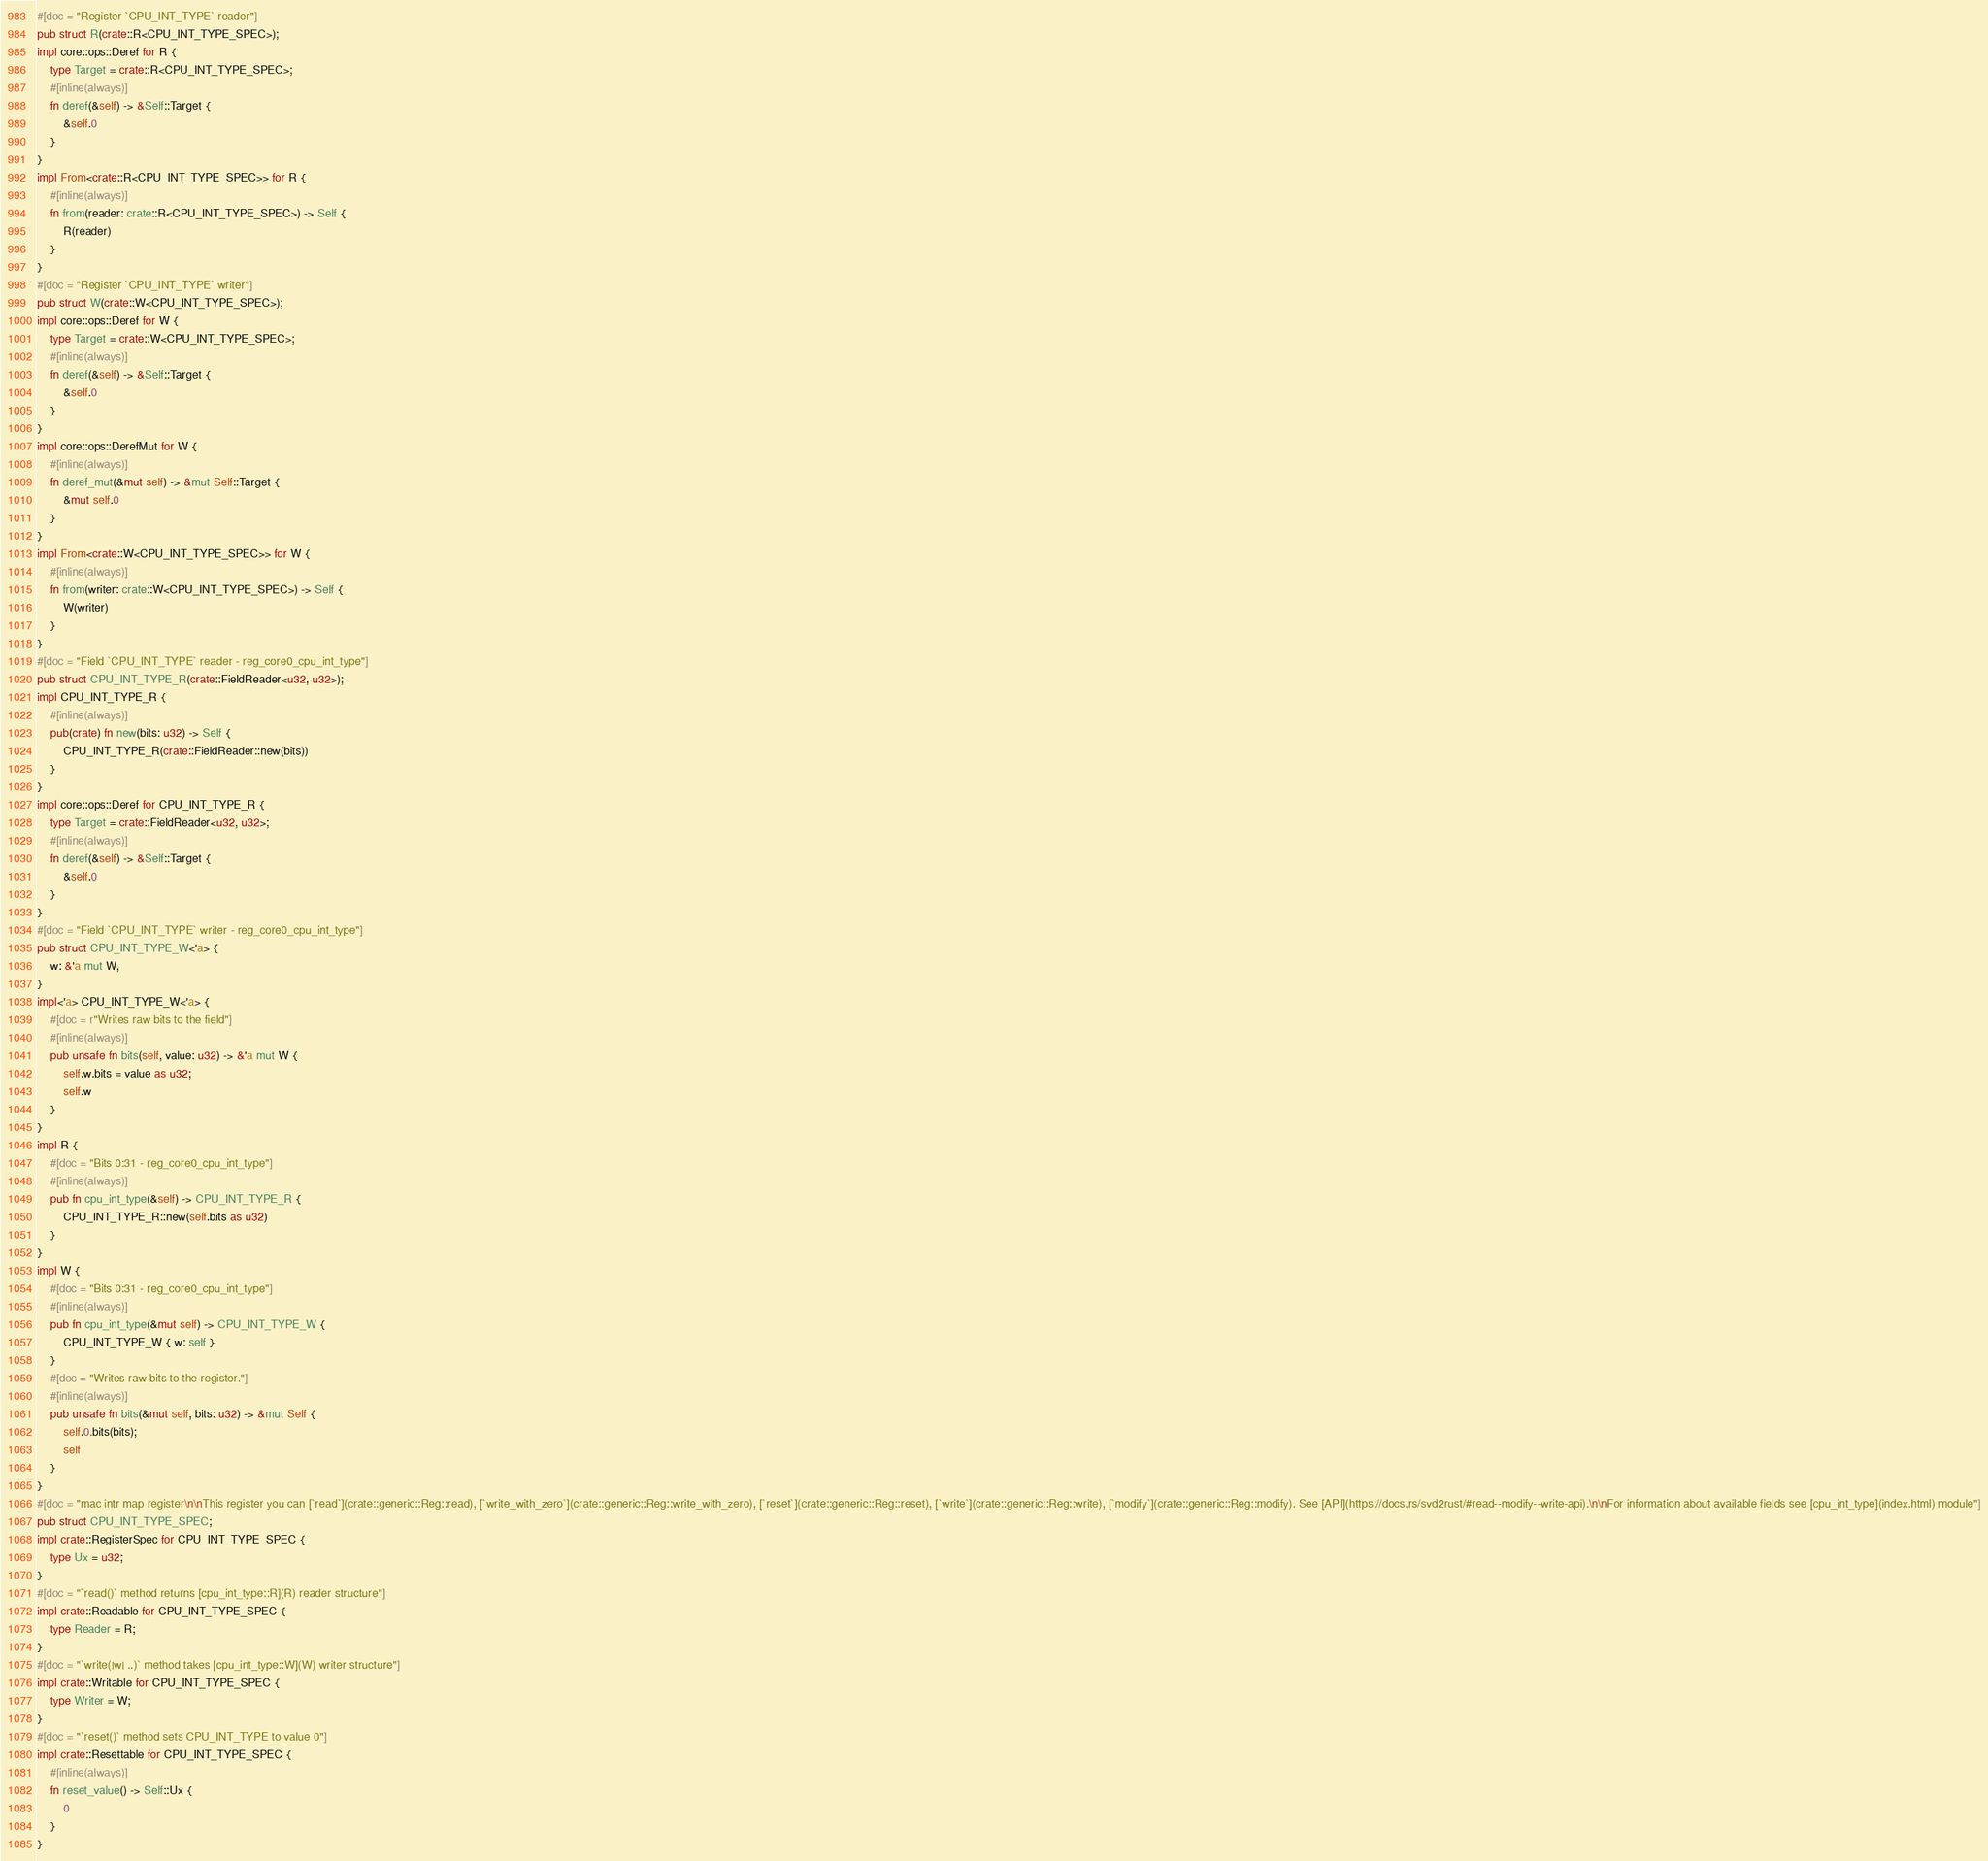<code> <loc_0><loc_0><loc_500><loc_500><_Rust_>#[doc = "Register `CPU_INT_TYPE` reader"]
pub struct R(crate::R<CPU_INT_TYPE_SPEC>);
impl core::ops::Deref for R {
    type Target = crate::R<CPU_INT_TYPE_SPEC>;
    #[inline(always)]
    fn deref(&self) -> &Self::Target {
        &self.0
    }
}
impl From<crate::R<CPU_INT_TYPE_SPEC>> for R {
    #[inline(always)]
    fn from(reader: crate::R<CPU_INT_TYPE_SPEC>) -> Self {
        R(reader)
    }
}
#[doc = "Register `CPU_INT_TYPE` writer"]
pub struct W(crate::W<CPU_INT_TYPE_SPEC>);
impl core::ops::Deref for W {
    type Target = crate::W<CPU_INT_TYPE_SPEC>;
    #[inline(always)]
    fn deref(&self) -> &Self::Target {
        &self.0
    }
}
impl core::ops::DerefMut for W {
    #[inline(always)]
    fn deref_mut(&mut self) -> &mut Self::Target {
        &mut self.0
    }
}
impl From<crate::W<CPU_INT_TYPE_SPEC>> for W {
    #[inline(always)]
    fn from(writer: crate::W<CPU_INT_TYPE_SPEC>) -> Self {
        W(writer)
    }
}
#[doc = "Field `CPU_INT_TYPE` reader - reg_core0_cpu_int_type"]
pub struct CPU_INT_TYPE_R(crate::FieldReader<u32, u32>);
impl CPU_INT_TYPE_R {
    #[inline(always)]
    pub(crate) fn new(bits: u32) -> Self {
        CPU_INT_TYPE_R(crate::FieldReader::new(bits))
    }
}
impl core::ops::Deref for CPU_INT_TYPE_R {
    type Target = crate::FieldReader<u32, u32>;
    #[inline(always)]
    fn deref(&self) -> &Self::Target {
        &self.0
    }
}
#[doc = "Field `CPU_INT_TYPE` writer - reg_core0_cpu_int_type"]
pub struct CPU_INT_TYPE_W<'a> {
    w: &'a mut W,
}
impl<'a> CPU_INT_TYPE_W<'a> {
    #[doc = r"Writes raw bits to the field"]
    #[inline(always)]
    pub unsafe fn bits(self, value: u32) -> &'a mut W {
        self.w.bits = value as u32;
        self.w
    }
}
impl R {
    #[doc = "Bits 0:31 - reg_core0_cpu_int_type"]
    #[inline(always)]
    pub fn cpu_int_type(&self) -> CPU_INT_TYPE_R {
        CPU_INT_TYPE_R::new(self.bits as u32)
    }
}
impl W {
    #[doc = "Bits 0:31 - reg_core0_cpu_int_type"]
    #[inline(always)]
    pub fn cpu_int_type(&mut self) -> CPU_INT_TYPE_W {
        CPU_INT_TYPE_W { w: self }
    }
    #[doc = "Writes raw bits to the register."]
    #[inline(always)]
    pub unsafe fn bits(&mut self, bits: u32) -> &mut Self {
        self.0.bits(bits);
        self
    }
}
#[doc = "mac intr map register\n\nThis register you can [`read`](crate::generic::Reg::read), [`write_with_zero`](crate::generic::Reg::write_with_zero), [`reset`](crate::generic::Reg::reset), [`write`](crate::generic::Reg::write), [`modify`](crate::generic::Reg::modify). See [API](https://docs.rs/svd2rust/#read--modify--write-api).\n\nFor information about available fields see [cpu_int_type](index.html) module"]
pub struct CPU_INT_TYPE_SPEC;
impl crate::RegisterSpec for CPU_INT_TYPE_SPEC {
    type Ux = u32;
}
#[doc = "`read()` method returns [cpu_int_type::R](R) reader structure"]
impl crate::Readable for CPU_INT_TYPE_SPEC {
    type Reader = R;
}
#[doc = "`write(|w| ..)` method takes [cpu_int_type::W](W) writer structure"]
impl crate::Writable for CPU_INT_TYPE_SPEC {
    type Writer = W;
}
#[doc = "`reset()` method sets CPU_INT_TYPE to value 0"]
impl crate::Resettable for CPU_INT_TYPE_SPEC {
    #[inline(always)]
    fn reset_value() -> Self::Ux {
        0
    }
}
</code> 